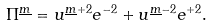Convert formula to latex. <formula><loc_0><loc_0><loc_500><loc_500>\Pi ^ { \underline { m } } = u ^ { \underline { m } + 2 } e ^ { - 2 } + u ^ { \underline { m } - 2 } e ^ { + 2 } .</formula> 